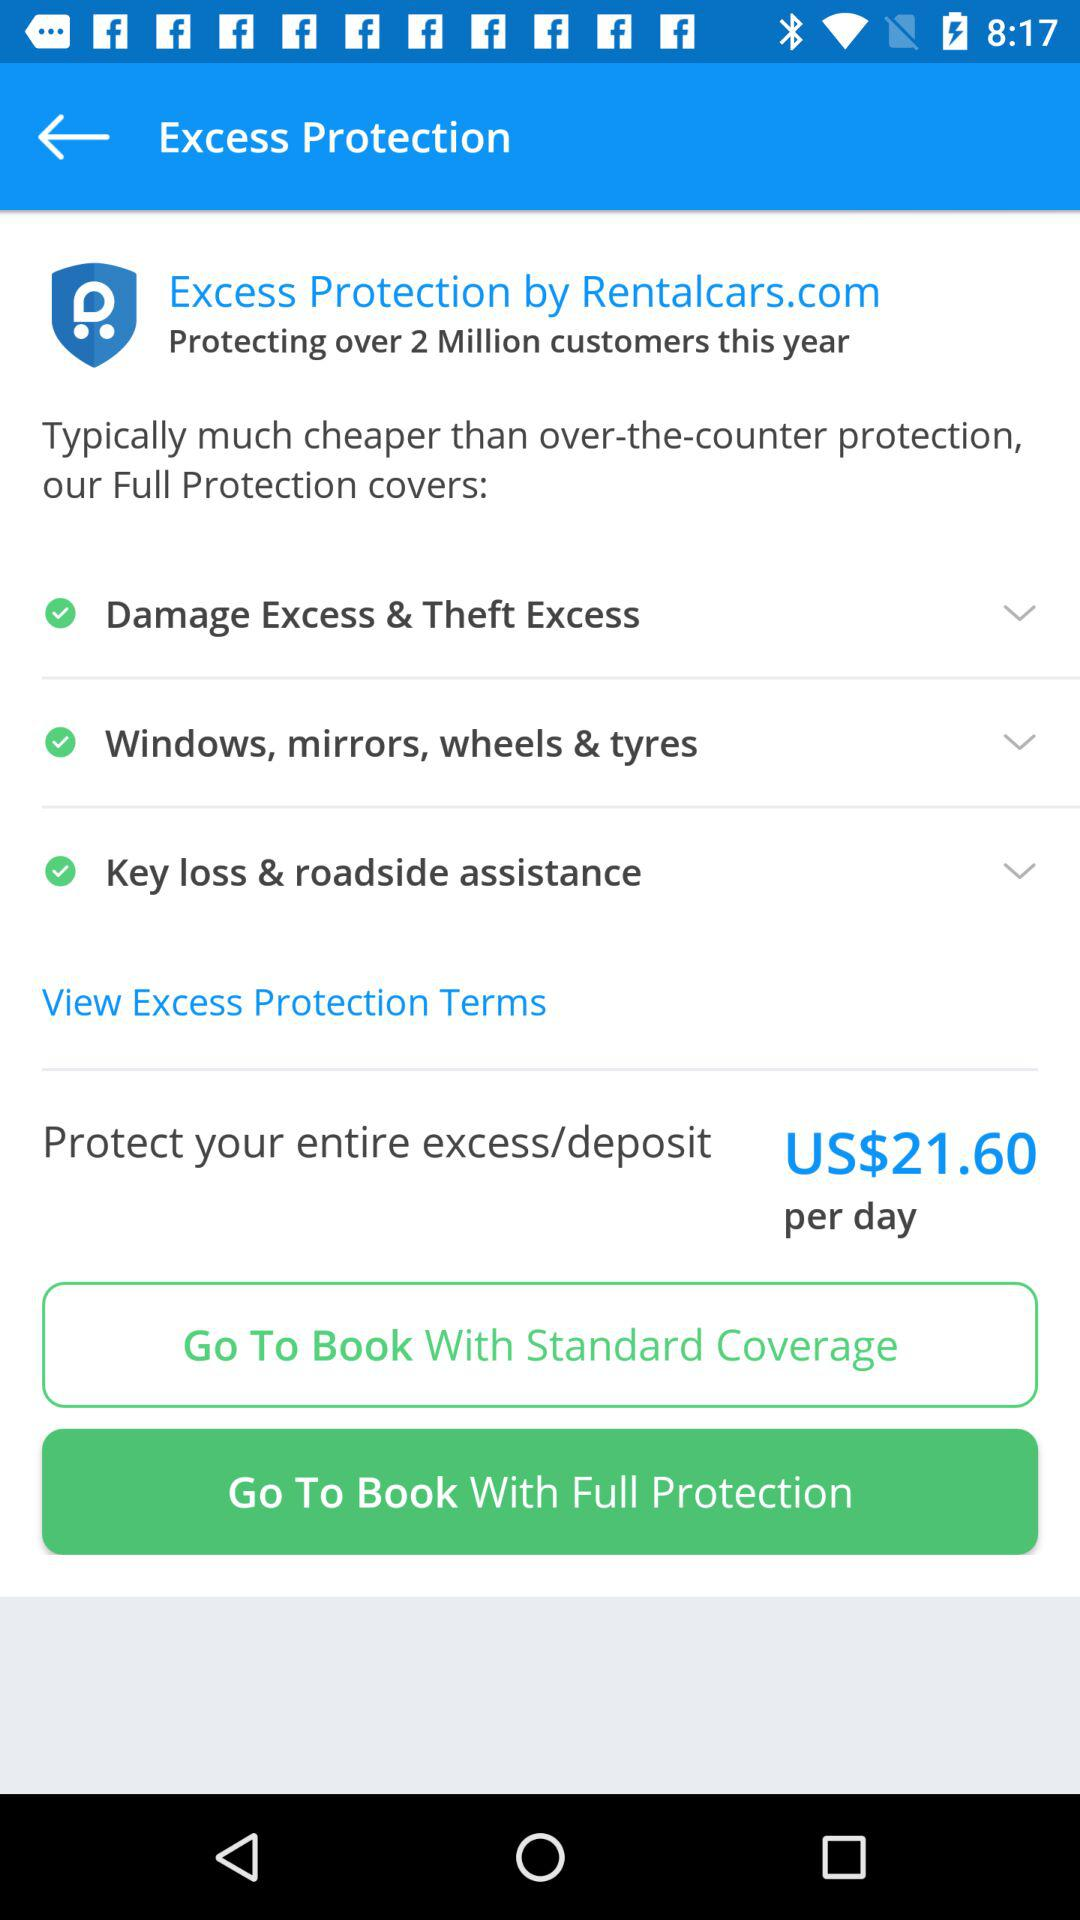How many items does the full protection cover?
Answer the question using a single word or phrase. 3 